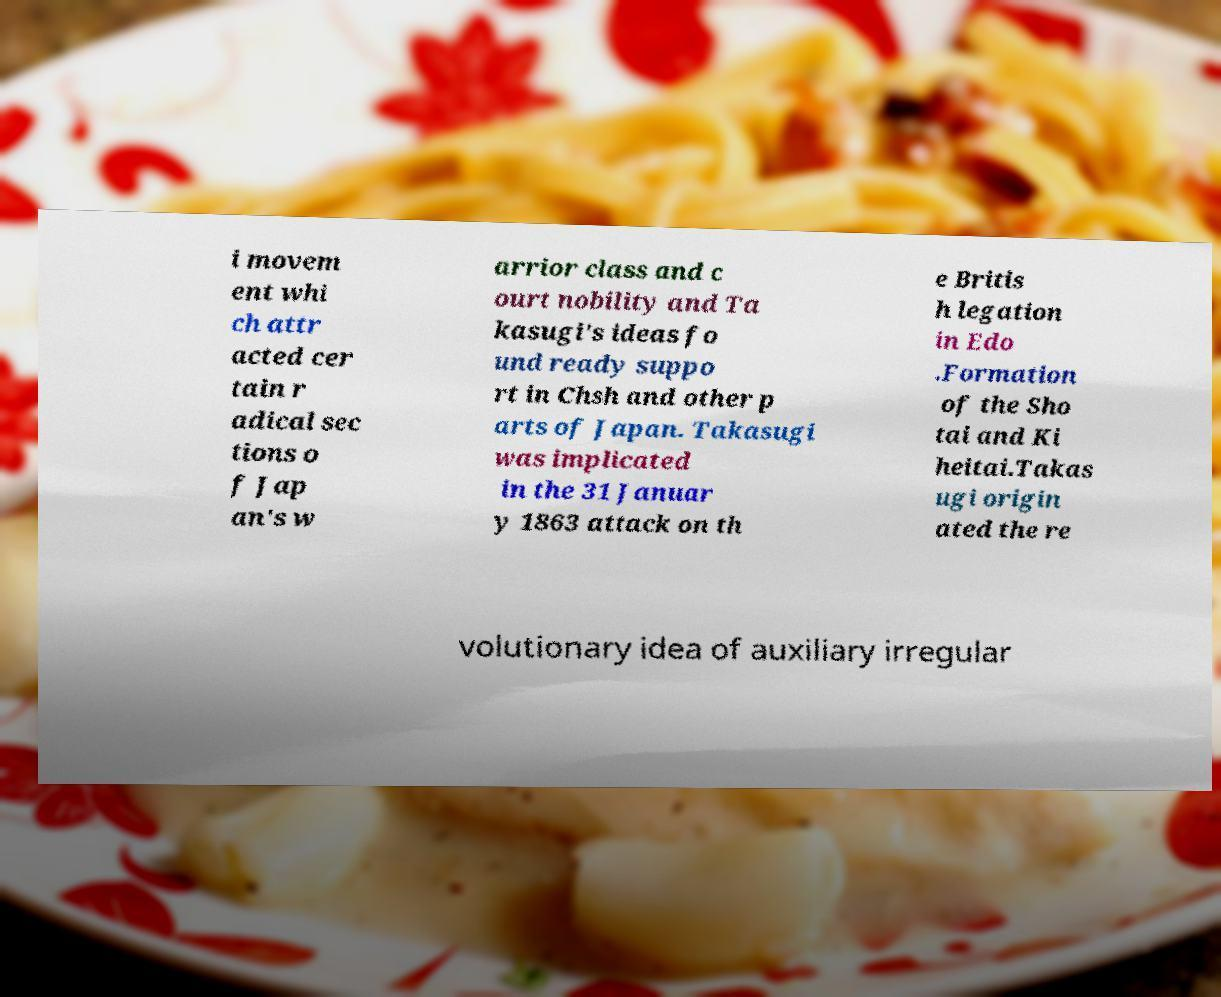Please identify and transcribe the text found in this image. i movem ent whi ch attr acted cer tain r adical sec tions o f Jap an's w arrior class and c ourt nobility and Ta kasugi's ideas fo und ready suppo rt in Chsh and other p arts of Japan. Takasugi was implicated in the 31 Januar y 1863 attack on th e Britis h legation in Edo .Formation of the Sho tai and Ki heitai.Takas ugi origin ated the re volutionary idea of auxiliary irregular 